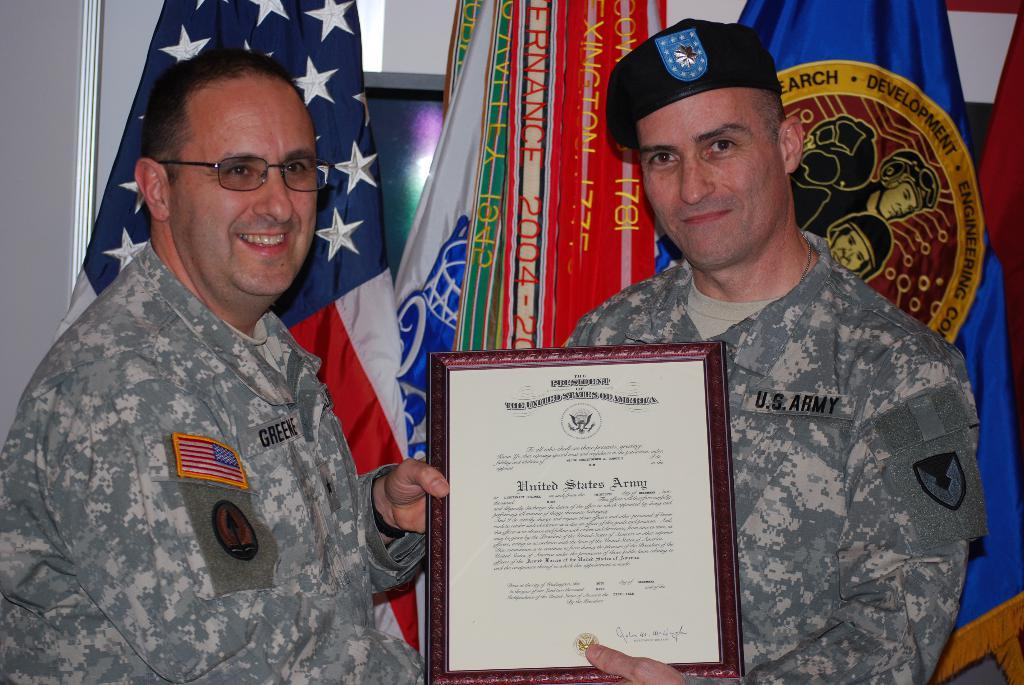How many people are in the image? There are two men in the image. What are the men wearing? The men are wearing army dresses. What are the men holding in the image? The men are holding a frame. What can be seen in the background of the image? There are flags in the background of the image. What is located to the left of the image? There is a wall to the left of the image. What type of lumber is being used to build the bath in the image? There is no bath or lumber present in the image. What historical event is being commemorated by the men in the image? The provided facts do not mention any historical event or commemoration; the men are simply wearing army dresses and holding a frame. 